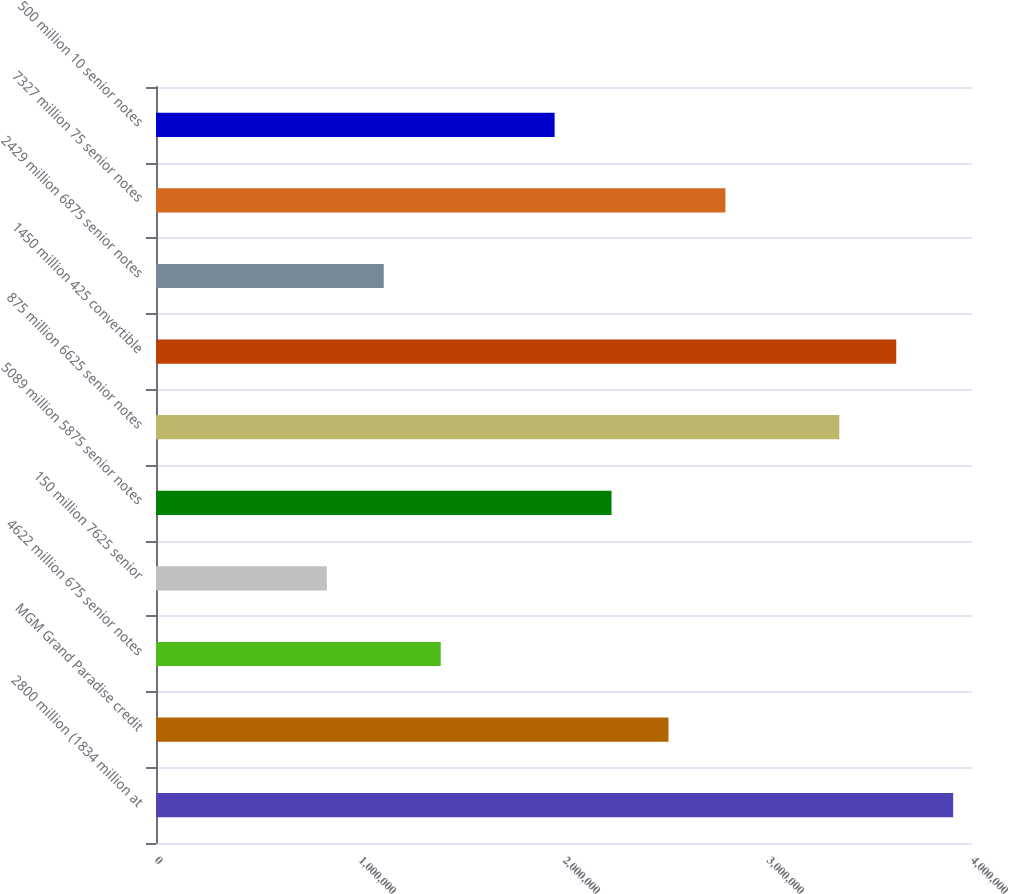<chart> <loc_0><loc_0><loc_500><loc_500><bar_chart><fcel>2800 million (1834 million at<fcel>MGM Grand Paradise credit<fcel>4622 million 675 senior notes<fcel>150 million 7625 senior<fcel>5089 million 5875 senior notes<fcel>875 million 6625 senior notes<fcel>1450 million 425 convertible<fcel>2429 million 6875 senior notes<fcel>7327 million 75 senior notes<fcel>500 million 10 senior notes<nl><fcel>3.90778e+06<fcel>2.51216e+06<fcel>1.39566e+06<fcel>837410<fcel>2.23303e+06<fcel>3.34953e+06<fcel>3.62866e+06<fcel>1.11654e+06<fcel>2.79128e+06<fcel>1.95391e+06<nl></chart> 